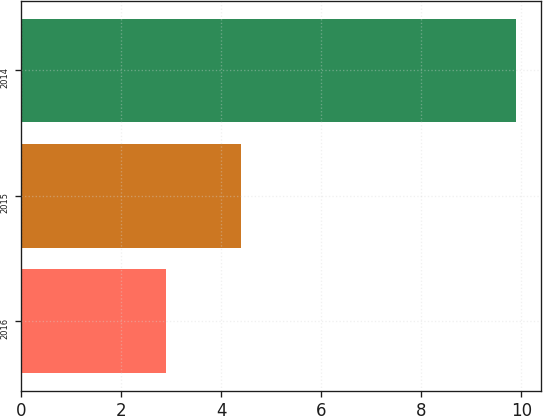Convert chart to OTSL. <chart><loc_0><loc_0><loc_500><loc_500><bar_chart><fcel>2016<fcel>2015<fcel>2014<nl><fcel>2.9<fcel>4.4<fcel>9.9<nl></chart> 